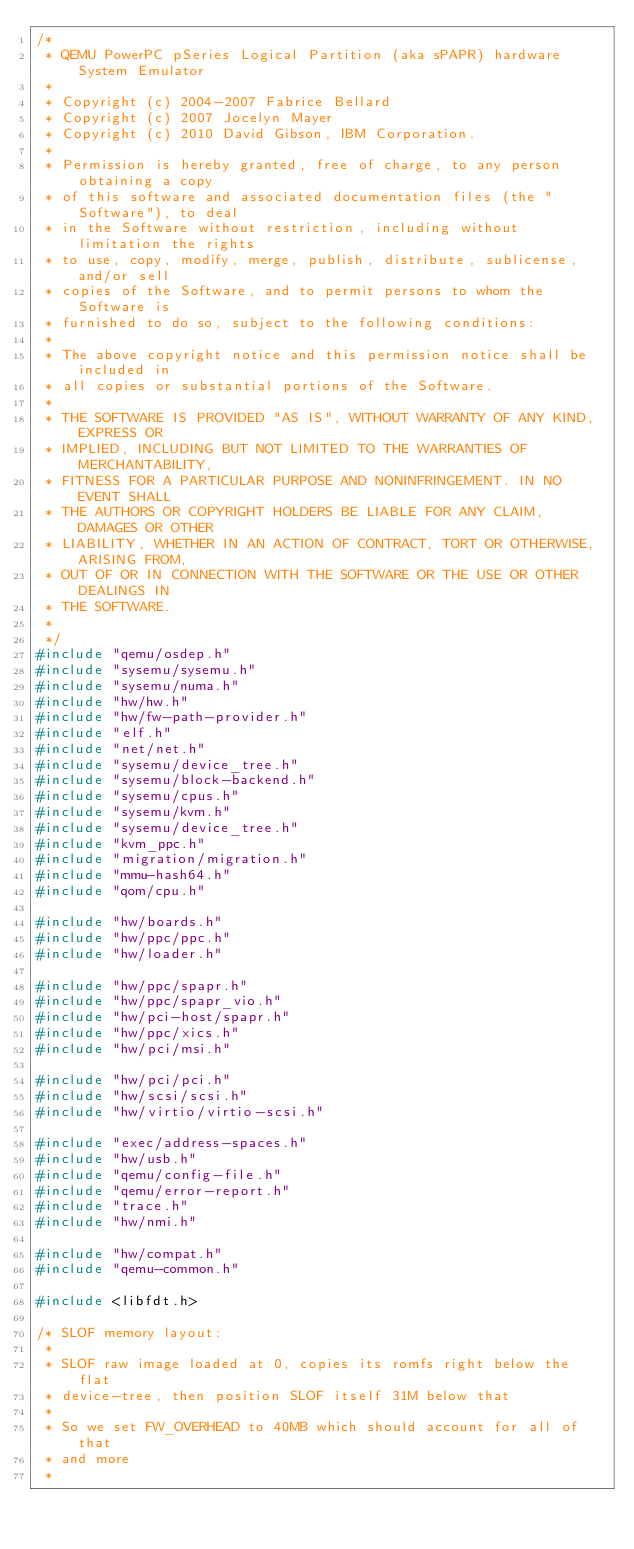Convert code to text. <code><loc_0><loc_0><loc_500><loc_500><_C_>/*
 * QEMU PowerPC pSeries Logical Partition (aka sPAPR) hardware System Emulator
 *
 * Copyright (c) 2004-2007 Fabrice Bellard
 * Copyright (c) 2007 Jocelyn Mayer
 * Copyright (c) 2010 David Gibson, IBM Corporation.
 *
 * Permission is hereby granted, free of charge, to any person obtaining a copy
 * of this software and associated documentation files (the "Software"), to deal
 * in the Software without restriction, including without limitation the rights
 * to use, copy, modify, merge, publish, distribute, sublicense, and/or sell
 * copies of the Software, and to permit persons to whom the Software is
 * furnished to do so, subject to the following conditions:
 *
 * The above copyright notice and this permission notice shall be included in
 * all copies or substantial portions of the Software.
 *
 * THE SOFTWARE IS PROVIDED "AS IS", WITHOUT WARRANTY OF ANY KIND, EXPRESS OR
 * IMPLIED, INCLUDING BUT NOT LIMITED TO THE WARRANTIES OF MERCHANTABILITY,
 * FITNESS FOR A PARTICULAR PURPOSE AND NONINFRINGEMENT. IN NO EVENT SHALL
 * THE AUTHORS OR COPYRIGHT HOLDERS BE LIABLE FOR ANY CLAIM, DAMAGES OR OTHER
 * LIABILITY, WHETHER IN AN ACTION OF CONTRACT, TORT OR OTHERWISE, ARISING FROM,
 * OUT OF OR IN CONNECTION WITH THE SOFTWARE OR THE USE OR OTHER DEALINGS IN
 * THE SOFTWARE.
 *
 */
#include "qemu/osdep.h"
#include "sysemu/sysemu.h"
#include "sysemu/numa.h"
#include "hw/hw.h"
#include "hw/fw-path-provider.h"
#include "elf.h"
#include "net/net.h"
#include "sysemu/device_tree.h"
#include "sysemu/block-backend.h"
#include "sysemu/cpus.h"
#include "sysemu/kvm.h"
#include "sysemu/device_tree.h"
#include "kvm_ppc.h"
#include "migration/migration.h"
#include "mmu-hash64.h"
#include "qom/cpu.h"

#include "hw/boards.h"
#include "hw/ppc/ppc.h"
#include "hw/loader.h"

#include "hw/ppc/spapr.h"
#include "hw/ppc/spapr_vio.h"
#include "hw/pci-host/spapr.h"
#include "hw/ppc/xics.h"
#include "hw/pci/msi.h"

#include "hw/pci/pci.h"
#include "hw/scsi/scsi.h"
#include "hw/virtio/virtio-scsi.h"

#include "exec/address-spaces.h"
#include "hw/usb.h"
#include "qemu/config-file.h"
#include "qemu/error-report.h"
#include "trace.h"
#include "hw/nmi.h"

#include "hw/compat.h"
#include "qemu-common.h"

#include <libfdt.h>

/* SLOF memory layout:
 *
 * SLOF raw image loaded at 0, copies its romfs right below the flat
 * device-tree, then position SLOF itself 31M below that
 *
 * So we set FW_OVERHEAD to 40MB which should account for all of that
 * and more
 *</code> 